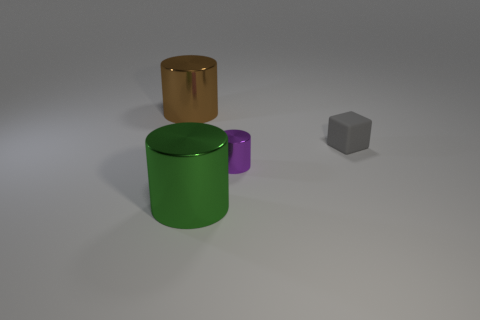Add 3 big green shiny things. How many objects exist? 7 Subtract all cylinders. How many objects are left? 1 Subtract 0 red cylinders. How many objects are left? 4 Subtract all small gray matte cylinders. Subtract all big brown objects. How many objects are left? 3 Add 4 big green objects. How many big green objects are left? 5 Add 1 large brown metallic cylinders. How many large brown metallic cylinders exist? 2 